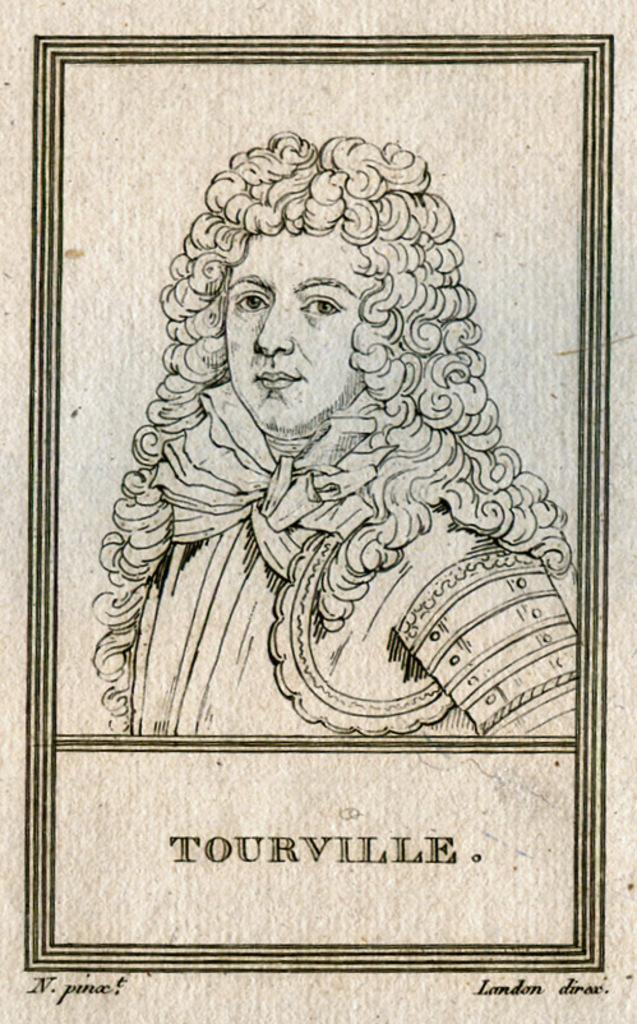What is depicted in the center of the image? There is a sketch of a man in the image. What surrounds the sketch in the image? There is a border around the page in the image. What can be found at the bottom of the image? There is text at the bottom of the image. What type of soda is being poured into the cellar in the image? There is no soda or cellar present in the image; it features a sketch of a man with a border and text at the bottom. What sound can be heard coming from the man in the image? The image is a sketch, so it does not produce any sound. 